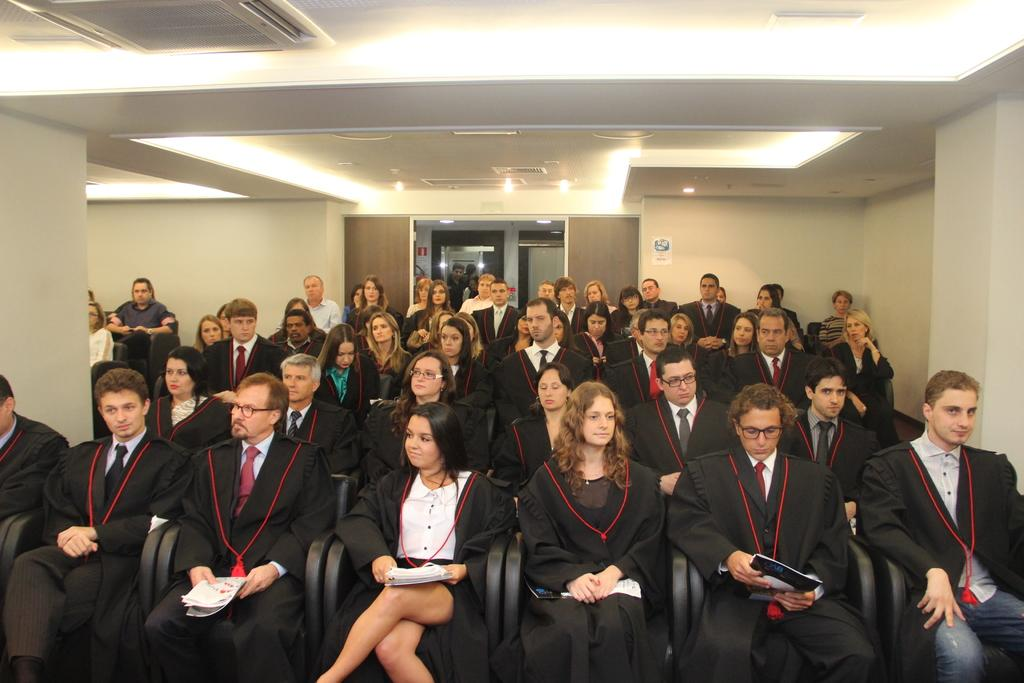How many people are in the image? There is a group of persons in the image. What color are the clothes worn by the persons in the image? The persons are wearing black color dress. What are the persons doing in the image? The persons are sitting on chairs. What can be seen in the background of the image? There is a wall in the background of the image. What type of vegetable is being served on the top of the wall in the image? There is no vegetable or any food item present on the wall in the image. 